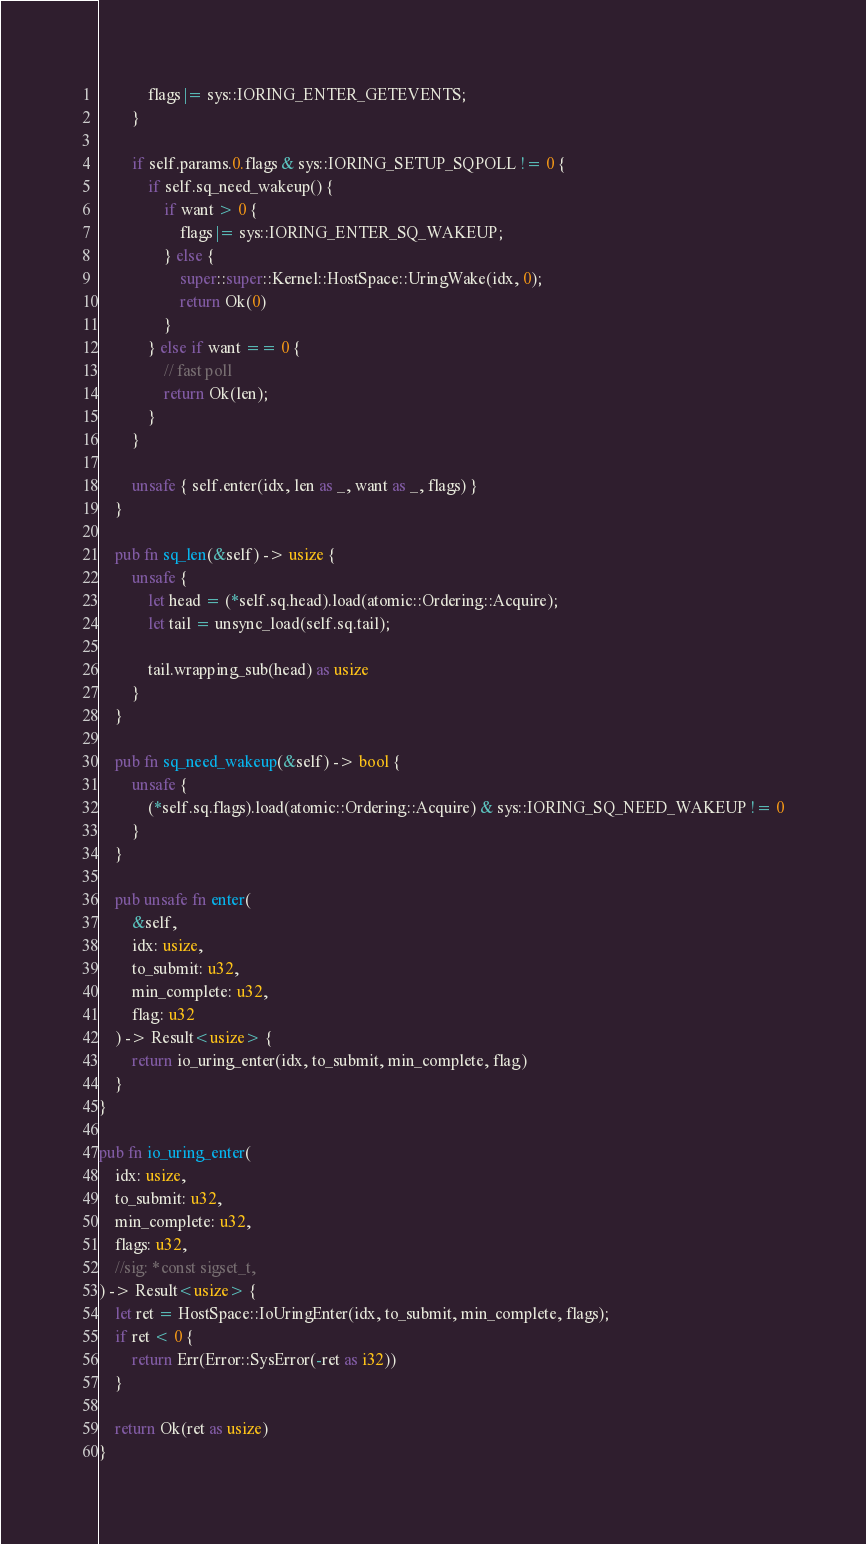<code> <loc_0><loc_0><loc_500><loc_500><_Rust_>            flags |= sys::IORING_ENTER_GETEVENTS;
        }

        if self.params.0.flags & sys::IORING_SETUP_SQPOLL != 0 {
            if self.sq_need_wakeup() {
                if want > 0 {
                    flags |= sys::IORING_ENTER_SQ_WAKEUP;
                } else {
                    super::super::Kernel::HostSpace::UringWake(idx, 0);
                    return Ok(0)
                }
            } else if want == 0 {
                // fast poll
                return Ok(len);
            }
        }

        unsafe { self.enter(idx, len as _, want as _, flags) }
    }

    pub fn sq_len(&self) -> usize {
        unsafe {
            let head = (*self.sq.head).load(atomic::Ordering::Acquire);
            let tail = unsync_load(self.sq.tail);

            tail.wrapping_sub(head) as usize
        }
    }

    pub fn sq_need_wakeup(&self) -> bool {
        unsafe {
            (*self.sq.flags).load(atomic::Ordering::Acquire) & sys::IORING_SQ_NEED_WAKEUP != 0
        }
    }

    pub unsafe fn enter(
        &self,
        idx: usize,
        to_submit: u32,
        min_complete: u32,
        flag: u32
    ) -> Result<usize> {
        return io_uring_enter(idx, to_submit, min_complete, flag)
    }
}

pub fn io_uring_enter(
    idx: usize,
    to_submit: u32,
    min_complete: u32,
    flags: u32,
    //sig: *const sigset_t,
) -> Result<usize> {
    let ret = HostSpace::IoUringEnter(idx, to_submit, min_complete, flags);
    if ret < 0 {
        return Err(Error::SysError(-ret as i32))
    }

    return Ok(ret as usize)
}</code> 